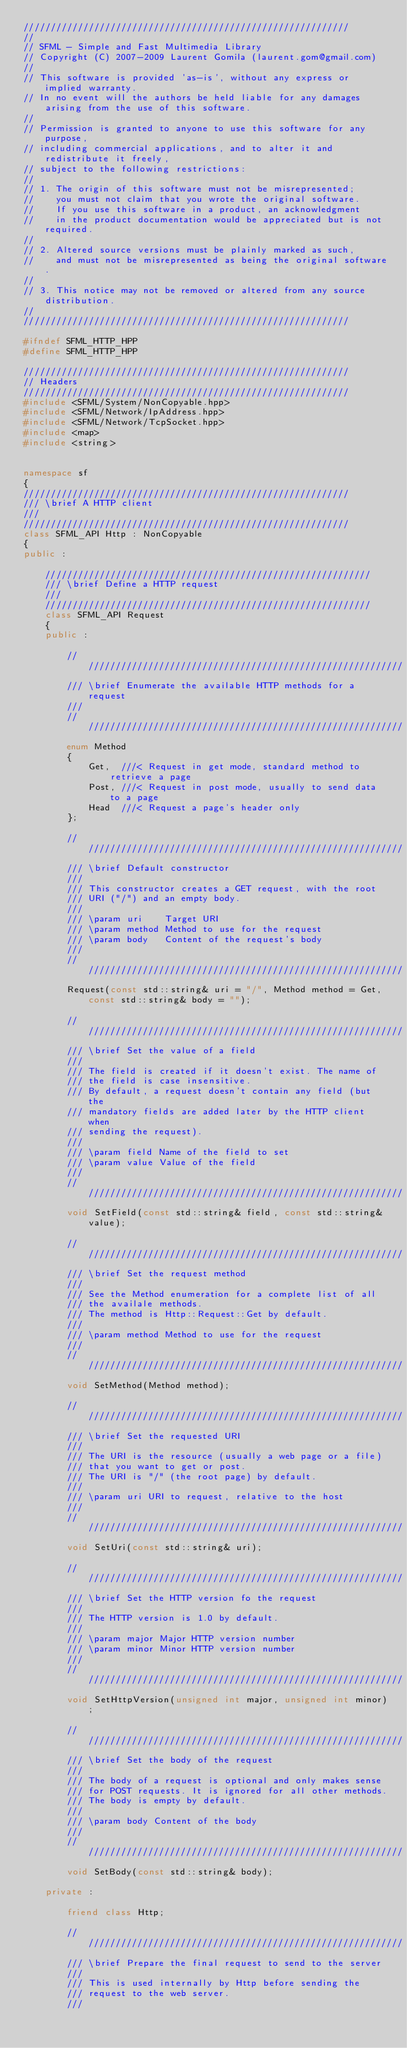<code> <loc_0><loc_0><loc_500><loc_500><_C++_>////////////////////////////////////////////////////////////
//
// SFML - Simple and Fast Multimedia Library
// Copyright (C) 2007-2009 Laurent Gomila (laurent.gom@gmail.com)
//
// This software is provided 'as-is', without any express or implied warranty.
// In no event will the authors be held liable for any damages arising from the use of this software.
//
// Permission is granted to anyone to use this software for any purpose,
// including commercial applications, and to alter it and redistribute it freely,
// subject to the following restrictions:
//
// 1. The origin of this software must not be misrepresented;
//    you must not claim that you wrote the original software.
//    If you use this software in a product, an acknowledgment
//    in the product documentation would be appreciated but is not required.
//
// 2. Altered source versions must be plainly marked as such,
//    and must not be misrepresented as being the original software.
//
// 3. This notice may not be removed or altered from any source distribution.
//
////////////////////////////////////////////////////////////

#ifndef SFML_HTTP_HPP
#define SFML_HTTP_HPP

////////////////////////////////////////////////////////////
// Headers
////////////////////////////////////////////////////////////
#include <SFML/System/NonCopyable.hpp>
#include <SFML/Network/IpAddress.hpp>
#include <SFML/Network/TcpSocket.hpp>
#include <map>
#include <string>


namespace sf
{
////////////////////////////////////////////////////////////
/// \brief A HTTP client
///
////////////////////////////////////////////////////////////
class SFML_API Http : NonCopyable
{
public :

    ////////////////////////////////////////////////////////////
    /// \brief Define a HTTP request
    ///
    ////////////////////////////////////////////////////////////
    class SFML_API Request
    {
    public :

        ////////////////////////////////////////////////////////////
        /// \brief Enumerate the available HTTP methods for a request
        ///
        ////////////////////////////////////////////////////////////
        enum Method
        {
            Get,  ///< Request in get mode, standard method to retrieve a page
            Post, ///< Request in post mode, usually to send data to a page
            Head  ///< Request a page's header only
        };

        ////////////////////////////////////////////////////////////
        /// \brief Default constructor
        ///
        /// This constructor creates a GET request, with the root
        /// URI ("/") and an empty body.
        ///
        /// \param uri    Target URI
        /// \param method Method to use for the request
        /// \param body   Content of the request's body
        ///
        ////////////////////////////////////////////////////////////
        Request(const std::string& uri = "/", Method method = Get, const std::string& body = "");

        ////////////////////////////////////////////////////////////
        /// \brief Set the value of a field
        ///
        /// The field is created if it doesn't exist. The name of
        /// the field is case insensitive.
        /// By default, a request doesn't contain any field (but the
        /// mandatory fields are added later by the HTTP client when
        /// sending the request).
        ///
        /// \param field Name of the field to set
        /// \param value Value of the field
        ///
        ////////////////////////////////////////////////////////////
        void SetField(const std::string& field, const std::string& value);

        ////////////////////////////////////////////////////////////
        /// \brief Set the request method
        ///
        /// See the Method enumeration for a complete list of all
        /// the availale methods.
        /// The method is Http::Request::Get by default.
        ///
        /// \param method Method to use for the request
        ///
        ////////////////////////////////////////////////////////////
        void SetMethod(Method method);

        ////////////////////////////////////////////////////////////
        /// \brief Set the requested URI
        ///
        /// The URI is the resource (usually a web page or a file)
        /// that you want to get or post.
        /// The URI is "/" (the root page) by default.
        ///
        /// \param uri URI to request, relative to the host
        ///
        ////////////////////////////////////////////////////////////
        void SetUri(const std::string& uri);

        ////////////////////////////////////////////////////////////
        /// \brief Set the HTTP version fo the request
        ///
        /// The HTTP version is 1.0 by default.
        ///
        /// \param major Major HTTP version number
        /// \param minor Minor HTTP version number
        ///
        ////////////////////////////////////////////////////////////
        void SetHttpVersion(unsigned int major, unsigned int minor);

        ////////////////////////////////////////////////////////////
        /// \brief Set the body of the request
        ///
        /// The body of a request is optional and only makes sense
        /// for POST requests. It is ignored for all other methods.
        /// The body is empty by default.
        ///
        /// \param body Content of the body
        ///
        ////////////////////////////////////////////////////////////
        void SetBody(const std::string& body);

    private :

        friend class Http;

        ////////////////////////////////////////////////////////////
        /// \brief Prepare the final request to send to the server
        ///
        /// This is used internally by Http before sending the
        /// request to the web server.
        ///</code> 